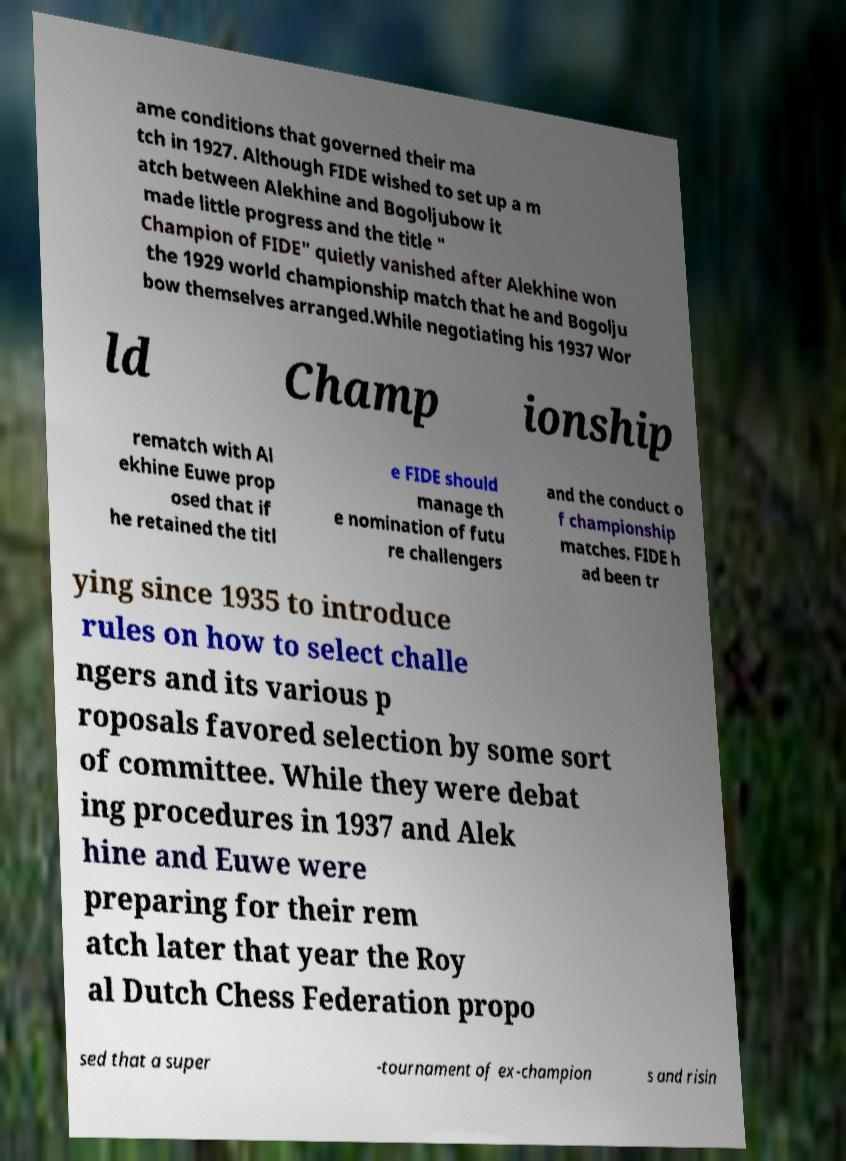Please identify and transcribe the text found in this image. ame conditions that governed their ma tch in 1927. Although FIDE wished to set up a m atch between Alekhine and Bogoljubow it made little progress and the title " Champion of FIDE" quietly vanished after Alekhine won the 1929 world championship match that he and Bogolju bow themselves arranged.While negotiating his 1937 Wor ld Champ ionship rematch with Al ekhine Euwe prop osed that if he retained the titl e FIDE should manage th e nomination of futu re challengers and the conduct o f championship matches. FIDE h ad been tr ying since 1935 to introduce rules on how to select challe ngers and its various p roposals favored selection by some sort of committee. While they were debat ing procedures in 1937 and Alek hine and Euwe were preparing for their rem atch later that year the Roy al Dutch Chess Federation propo sed that a super -tournament of ex-champion s and risin 